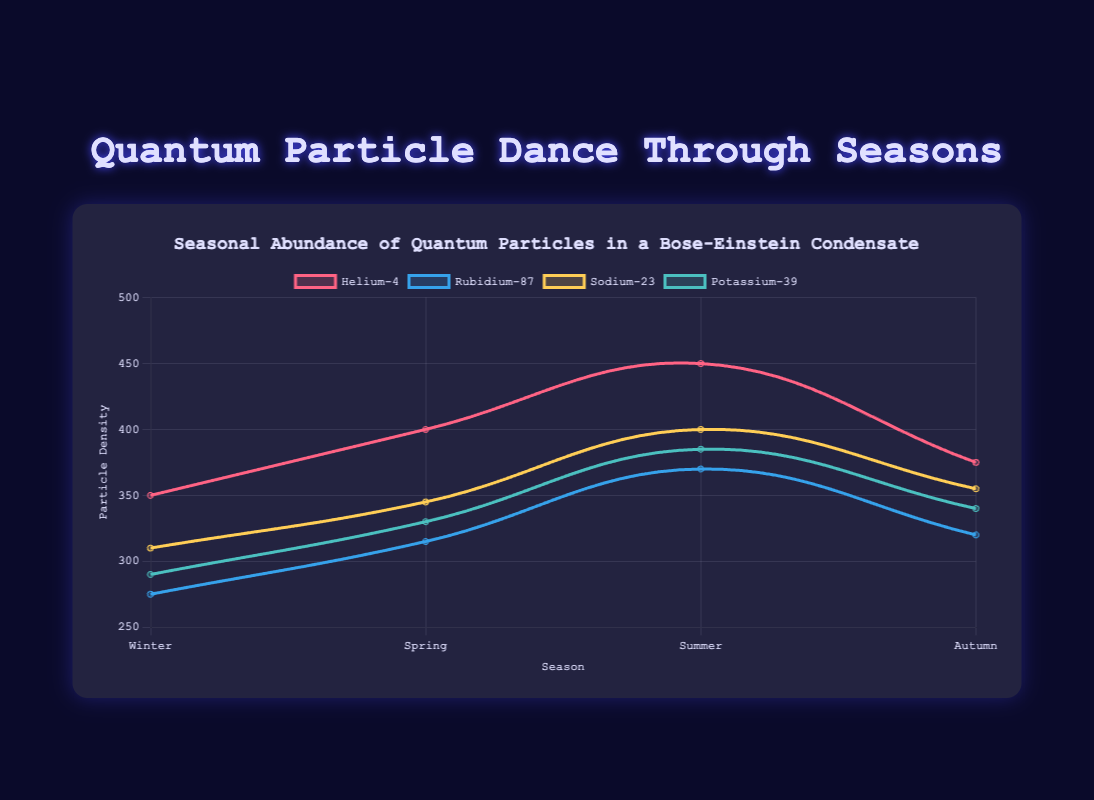What's the difference in particle density of Helium-4 between Summer and Winter? The particle density of Helium-4 in Summer is 450, and in Winter it is 350. The difference is 450 - 350 = 100
Answer: 100 Which particle has the highest density in Autumn? Looking at the Autumn column, Sodium-23 has the highest particle density with 355
Answer: Sodium-23 What's the average particle density of Rubidium-87 across all seasons? Sum up the densities for Rubidium-87 (275 + 315 + 370 + 320) = 1280. Then divide by 4 (number of seasons): 1280 / 4 = 320
Answer: 320 How does the density of Sodium-23 in Spring compare with Potassium-39 in Spring? In Spring, Sodium-23 has a density of 345 and Potassium-39 has a density of 330. Sodium-23 has a higher density
Answer: Sodium-23 has higher density What is the range of Helium-4 particle densities across the seasons? The highest density of Helium-4 is 450 in Summer, and the lowest is 350 in Winter. The range is 450 - 350 = 100
Answer: 100 Is the density of Potassium-39 higher in Winter or Autumn? In Winter, the density of Potassium-39 is 290, and in Autumn it is 340. Potassium-39 has a higher density in Autumn
Answer: Autumn Which season has the lowest density for Rubidium-87? Looking at the densities of Rubidium-87 in Winter (275), Spring (315), Summer (370), and Autumn (320), Winter has the lowest density
Answer: Winter What's the total particle density of all particles in Spring? Sum the densities of all particles in Spring: 400 (Helium-4) + 315 (Rubidium-87) + 345 (Sodium-23) + 330 (Potassium-39) = 1390
Answer: 1390 Which color line represents the density of Sodium-23? The color line for Sodium-23 is described as yellow in the chart's legend
Answer: Yellow What's the difference between the highest and lowest particle densities for Potassium-39? The highest density of Potassium-39 is 385 in Summer, and the lowest is 290 in Winter. The difference is 385 - 290 = 95
Answer: 95 